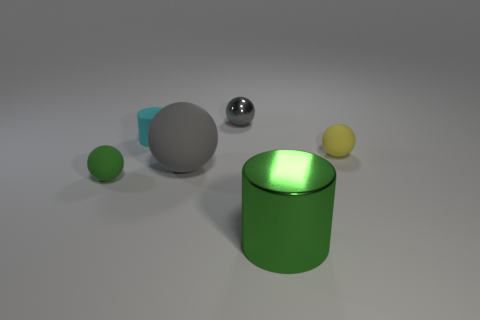Subtract all gray matte spheres. How many spheres are left? 3 Subtract all green cylinders. How many gray balls are left? 2 Add 4 tiny yellow matte spheres. How many objects exist? 10 Subtract all yellow balls. How many balls are left? 3 Subtract 2 cylinders. How many cylinders are left? 0 Subtract 1 cyan cylinders. How many objects are left? 5 Subtract all cylinders. How many objects are left? 4 Subtract all green cylinders. Subtract all yellow cubes. How many cylinders are left? 1 Subtract all small cyan things. Subtract all small yellow things. How many objects are left? 4 Add 6 green spheres. How many green spheres are left? 7 